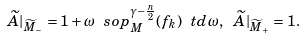<formula> <loc_0><loc_0><loc_500><loc_500>\widetilde { A } | _ { \widetilde { M } _ { - } } = 1 + \omega \ s o p _ { M } ^ { \gamma - \frac { n } { 2 } } ( f _ { k } ) \ t d \omega , \ \widetilde { A } | _ { \widetilde { M } _ { + } } = 1 .</formula> 